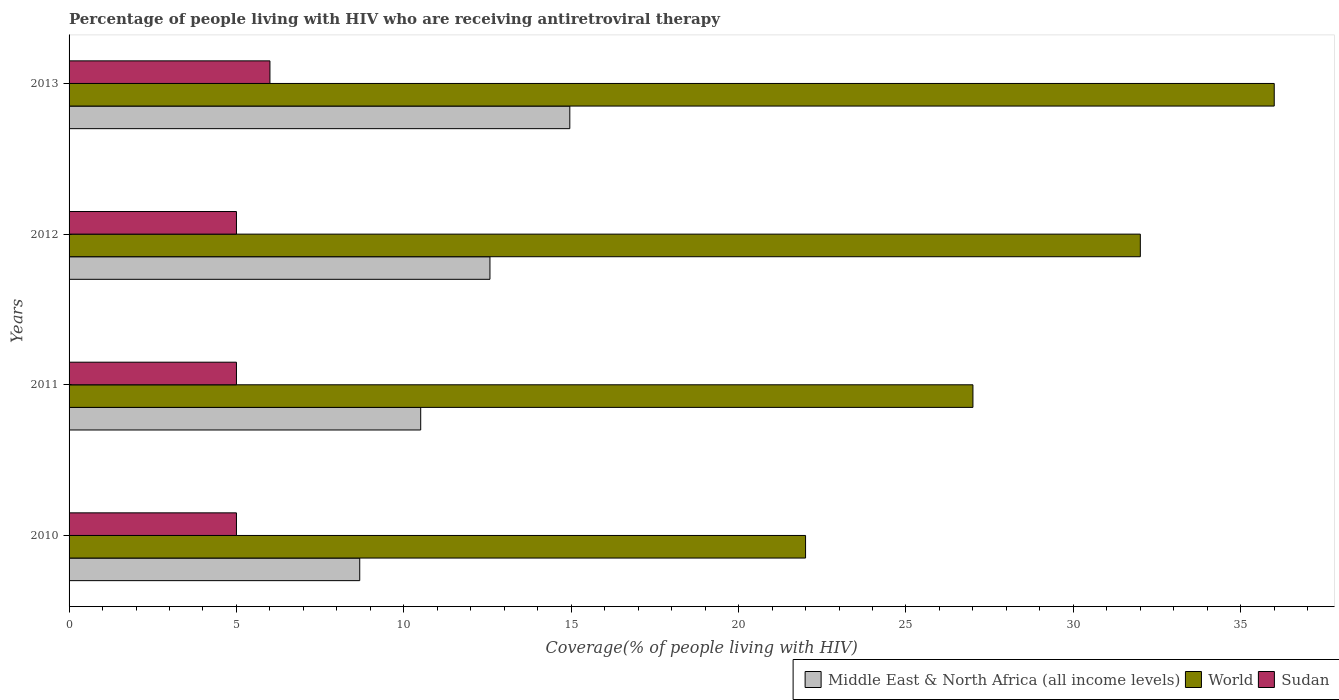How many different coloured bars are there?
Make the answer very short. 3. How many groups of bars are there?
Provide a short and direct response. 4. Are the number of bars per tick equal to the number of legend labels?
Keep it short and to the point. Yes. What is the percentage of the HIV infected people who are receiving antiretroviral therapy in Sudan in 2011?
Provide a succinct answer. 5. Across all years, what is the maximum percentage of the HIV infected people who are receiving antiretroviral therapy in World?
Your response must be concise. 36. Across all years, what is the minimum percentage of the HIV infected people who are receiving antiretroviral therapy in World?
Provide a short and direct response. 22. What is the total percentage of the HIV infected people who are receiving antiretroviral therapy in Middle East & North Africa (all income levels) in the graph?
Offer a terse response. 46.72. What is the difference between the percentage of the HIV infected people who are receiving antiretroviral therapy in Sudan in 2012 and that in 2013?
Give a very brief answer. -1. What is the difference between the percentage of the HIV infected people who are receiving antiretroviral therapy in Middle East & North Africa (all income levels) in 2011 and the percentage of the HIV infected people who are receiving antiretroviral therapy in Sudan in 2012?
Ensure brevity in your answer.  5.5. What is the average percentage of the HIV infected people who are receiving antiretroviral therapy in Middle East & North Africa (all income levels) per year?
Your answer should be very brief. 11.68. In the year 2010, what is the difference between the percentage of the HIV infected people who are receiving antiretroviral therapy in Middle East & North Africa (all income levels) and percentage of the HIV infected people who are receiving antiretroviral therapy in World?
Your answer should be very brief. -13.32. What is the ratio of the percentage of the HIV infected people who are receiving antiretroviral therapy in World in 2011 to that in 2013?
Your response must be concise. 0.75. Is the percentage of the HIV infected people who are receiving antiretroviral therapy in World in 2010 less than that in 2011?
Keep it short and to the point. Yes. What is the difference between the highest and the lowest percentage of the HIV infected people who are receiving antiretroviral therapy in World?
Make the answer very short. 14. In how many years, is the percentage of the HIV infected people who are receiving antiretroviral therapy in Sudan greater than the average percentage of the HIV infected people who are receiving antiretroviral therapy in Sudan taken over all years?
Make the answer very short. 1. Is it the case that in every year, the sum of the percentage of the HIV infected people who are receiving antiretroviral therapy in World and percentage of the HIV infected people who are receiving antiretroviral therapy in Middle East & North Africa (all income levels) is greater than the percentage of the HIV infected people who are receiving antiretroviral therapy in Sudan?
Provide a short and direct response. Yes. What is the difference between two consecutive major ticks on the X-axis?
Offer a terse response. 5. Are the values on the major ticks of X-axis written in scientific E-notation?
Keep it short and to the point. No. Does the graph contain any zero values?
Give a very brief answer. No. Where does the legend appear in the graph?
Keep it short and to the point. Bottom right. How many legend labels are there?
Offer a terse response. 3. How are the legend labels stacked?
Your response must be concise. Horizontal. What is the title of the graph?
Keep it short and to the point. Percentage of people living with HIV who are receiving antiretroviral therapy. What is the label or title of the X-axis?
Keep it short and to the point. Coverage(% of people living with HIV). What is the Coverage(% of people living with HIV) of Middle East & North Africa (all income levels) in 2010?
Make the answer very short. 8.68. What is the Coverage(% of people living with HIV) in Middle East & North Africa (all income levels) in 2011?
Your response must be concise. 10.5. What is the Coverage(% of people living with HIV) in Sudan in 2011?
Your response must be concise. 5. What is the Coverage(% of people living with HIV) in Middle East & North Africa (all income levels) in 2012?
Provide a succinct answer. 12.57. What is the Coverage(% of people living with HIV) of World in 2012?
Keep it short and to the point. 32. What is the Coverage(% of people living with HIV) of Sudan in 2012?
Keep it short and to the point. 5. What is the Coverage(% of people living with HIV) in Middle East & North Africa (all income levels) in 2013?
Your response must be concise. 14.96. Across all years, what is the maximum Coverage(% of people living with HIV) in Middle East & North Africa (all income levels)?
Provide a short and direct response. 14.96. Across all years, what is the minimum Coverage(% of people living with HIV) of Middle East & North Africa (all income levels)?
Your response must be concise. 8.68. Across all years, what is the minimum Coverage(% of people living with HIV) of Sudan?
Your answer should be compact. 5. What is the total Coverage(% of people living with HIV) of Middle East & North Africa (all income levels) in the graph?
Ensure brevity in your answer.  46.72. What is the total Coverage(% of people living with HIV) in World in the graph?
Offer a terse response. 117. What is the total Coverage(% of people living with HIV) of Sudan in the graph?
Your answer should be compact. 21. What is the difference between the Coverage(% of people living with HIV) in Middle East & North Africa (all income levels) in 2010 and that in 2011?
Keep it short and to the point. -1.82. What is the difference between the Coverage(% of people living with HIV) of World in 2010 and that in 2011?
Provide a short and direct response. -5. What is the difference between the Coverage(% of people living with HIV) of Sudan in 2010 and that in 2011?
Your answer should be very brief. 0. What is the difference between the Coverage(% of people living with HIV) of Middle East & North Africa (all income levels) in 2010 and that in 2012?
Ensure brevity in your answer.  -3.89. What is the difference between the Coverage(% of people living with HIV) in Middle East & North Africa (all income levels) in 2010 and that in 2013?
Offer a very short reply. -6.28. What is the difference between the Coverage(% of people living with HIV) in World in 2010 and that in 2013?
Provide a short and direct response. -14. What is the difference between the Coverage(% of people living with HIV) of Middle East & North Africa (all income levels) in 2011 and that in 2012?
Your response must be concise. -2.07. What is the difference between the Coverage(% of people living with HIV) of Middle East & North Africa (all income levels) in 2011 and that in 2013?
Ensure brevity in your answer.  -4.45. What is the difference between the Coverage(% of people living with HIV) of World in 2011 and that in 2013?
Your response must be concise. -9. What is the difference between the Coverage(% of people living with HIV) in Middle East & North Africa (all income levels) in 2012 and that in 2013?
Make the answer very short. -2.39. What is the difference between the Coverage(% of people living with HIV) of World in 2012 and that in 2013?
Provide a short and direct response. -4. What is the difference between the Coverage(% of people living with HIV) in Middle East & North Africa (all income levels) in 2010 and the Coverage(% of people living with HIV) in World in 2011?
Your answer should be very brief. -18.32. What is the difference between the Coverage(% of people living with HIV) of Middle East & North Africa (all income levels) in 2010 and the Coverage(% of people living with HIV) of Sudan in 2011?
Your response must be concise. 3.68. What is the difference between the Coverage(% of people living with HIV) in World in 2010 and the Coverage(% of people living with HIV) in Sudan in 2011?
Your response must be concise. 17. What is the difference between the Coverage(% of people living with HIV) of Middle East & North Africa (all income levels) in 2010 and the Coverage(% of people living with HIV) of World in 2012?
Give a very brief answer. -23.32. What is the difference between the Coverage(% of people living with HIV) of Middle East & North Africa (all income levels) in 2010 and the Coverage(% of people living with HIV) of Sudan in 2012?
Offer a terse response. 3.68. What is the difference between the Coverage(% of people living with HIV) in World in 2010 and the Coverage(% of people living with HIV) in Sudan in 2012?
Offer a terse response. 17. What is the difference between the Coverage(% of people living with HIV) in Middle East & North Africa (all income levels) in 2010 and the Coverage(% of people living with HIV) in World in 2013?
Keep it short and to the point. -27.32. What is the difference between the Coverage(% of people living with HIV) in Middle East & North Africa (all income levels) in 2010 and the Coverage(% of people living with HIV) in Sudan in 2013?
Ensure brevity in your answer.  2.68. What is the difference between the Coverage(% of people living with HIV) in World in 2010 and the Coverage(% of people living with HIV) in Sudan in 2013?
Keep it short and to the point. 16. What is the difference between the Coverage(% of people living with HIV) in Middle East & North Africa (all income levels) in 2011 and the Coverage(% of people living with HIV) in World in 2012?
Provide a succinct answer. -21.5. What is the difference between the Coverage(% of people living with HIV) of Middle East & North Africa (all income levels) in 2011 and the Coverage(% of people living with HIV) of Sudan in 2012?
Your answer should be very brief. 5.5. What is the difference between the Coverage(% of people living with HIV) in World in 2011 and the Coverage(% of people living with HIV) in Sudan in 2012?
Ensure brevity in your answer.  22. What is the difference between the Coverage(% of people living with HIV) of Middle East & North Africa (all income levels) in 2011 and the Coverage(% of people living with HIV) of World in 2013?
Keep it short and to the point. -25.5. What is the difference between the Coverage(% of people living with HIV) in Middle East & North Africa (all income levels) in 2011 and the Coverage(% of people living with HIV) in Sudan in 2013?
Offer a terse response. 4.5. What is the difference between the Coverage(% of people living with HIV) of Middle East & North Africa (all income levels) in 2012 and the Coverage(% of people living with HIV) of World in 2013?
Provide a short and direct response. -23.43. What is the difference between the Coverage(% of people living with HIV) in Middle East & North Africa (all income levels) in 2012 and the Coverage(% of people living with HIV) in Sudan in 2013?
Ensure brevity in your answer.  6.57. What is the difference between the Coverage(% of people living with HIV) of World in 2012 and the Coverage(% of people living with HIV) of Sudan in 2013?
Offer a terse response. 26. What is the average Coverage(% of people living with HIV) in Middle East & North Africa (all income levels) per year?
Give a very brief answer. 11.68. What is the average Coverage(% of people living with HIV) of World per year?
Give a very brief answer. 29.25. What is the average Coverage(% of people living with HIV) in Sudan per year?
Your answer should be compact. 5.25. In the year 2010, what is the difference between the Coverage(% of people living with HIV) of Middle East & North Africa (all income levels) and Coverage(% of people living with HIV) of World?
Give a very brief answer. -13.32. In the year 2010, what is the difference between the Coverage(% of people living with HIV) in Middle East & North Africa (all income levels) and Coverage(% of people living with HIV) in Sudan?
Give a very brief answer. 3.68. In the year 2011, what is the difference between the Coverage(% of people living with HIV) in Middle East & North Africa (all income levels) and Coverage(% of people living with HIV) in World?
Ensure brevity in your answer.  -16.5. In the year 2011, what is the difference between the Coverage(% of people living with HIV) in Middle East & North Africa (all income levels) and Coverage(% of people living with HIV) in Sudan?
Ensure brevity in your answer.  5.5. In the year 2011, what is the difference between the Coverage(% of people living with HIV) of World and Coverage(% of people living with HIV) of Sudan?
Your answer should be compact. 22. In the year 2012, what is the difference between the Coverage(% of people living with HIV) of Middle East & North Africa (all income levels) and Coverage(% of people living with HIV) of World?
Make the answer very short. -19.43. In the year 2012, what is the difference between the Coverage(% of people living with HIV) of Middle East & North Africa (all income levels) and Coverage(% of people living with HIV) of Sudan?
Provide a succinct answer. 7.57. In the year 2012, what is the difference between the Coverage(% of people living with HIV) in World and Coverage(% of people living with HIV) in Sudan?
Offer a terse response. 27. In the year 2013, what is the difference between the Coverage(% of people living with HIV) in Middle East & North Africa (all income levels) and Coverage(% of people living with HIV) in World?
Provide a short and direct response. -21.04. In the year 2013, what is the difference between the Coverage(% of people living with HIV) in Middle East & North Africa (all income levels) and Coverage(% of people living with HIV) in Sudan?
Your answer should be compact. 8.96. What is the ratio of the Coverage(% of people living with HIV) of Middle East & North Africa (all income levels) in 2010 to that in 2011?
Ensure brevity in your answer.  0.83. What is the ratio of the Coverage(% of people living with HIV) in World in 2010 to that in 2011?
Your answer should be compact. 0.81. What is the ratio of the Coverage(% of people living with HIV) in Sudan in 2010 to that in 2011?
Provide a succinct answer. 1. What is the ratio of the Coverage(% of people living with HIV) in Middle East & North Africa (all income levels) in 2010 to that in 2012?
Offer a very short reply. 0.69. What is the ratio of the Coverage(% of people living with HIV) in World in 2010 to that in 2012?
Your response must be concise. 0.69. What is the ratio of the Coverage(% of people living with HIV) in Sudan in 2010 to that in 2012?
Keep it short and to the point. 1. What is the ratio of the Coverage(% of people living with HIV) of Middle East & North Africa (all income levels) in 2010 to that in 2013?
Your answer should be very brief. 0.58. What is the ratio of the Coverage(% of people living with HIV) of World in 2010 to that in 2013?
Offer a terse response. 0.61. What is the ratio of the Coverage(% of people living with HIV) of Sudan in 2010 to that in 2013?
Provide a short and direct response. 0.83. What is the ratio of the Coverage(% of people living with HIV) in Middle East & North Africa (all income levels) in 2011 to that in 2012?
Your answer should be very brief. 0.84. What is the ratio of the Coverage(% of people living with HIV) of World in 2011 to that in 2012?
Your answer should be very brief. 0.84. What is the ratio of the Coverage(% of people living with HIV) in Sudan in 2011 to that in 2012?
Your answer should be compact. 1. What is the ratio of the Coverage(% of people living with HIV) in Middle East & North Africa (all income levels) in 2011 to that in 2013?
Ensure brevity in your answer.  0.7. What is the ratio of the Coverage(% of people living with HIV) of Sudan in 2011 to that in 2013?
Offer a very short reply. 0.83. What is the ratio of the Coverage(% of people living with HIV) of Middle East & North Africa (all income levels) in 2012 to that in 2013?
Keep it short and to the point. 0.84. What is the ratio of the Coverage(% of people living with HIV) of World in 2012 to that in 2013?
Your answer should be compact. 0.89. What is the difference between the highest and the second highest Coverage(% of people living with HIV) in Middle East & North Africa (all income levels)?
Keep it short and to the point. 2.39. What is the difference between the highest and the second highest Coverage(% of people living with HIV) of Sudan?
Your answer should be compact. 1. What is the difference between the highest and the lowest Coverage(% of people living with HIV) of Middle East & North Africa (all income levels)?
Offer a terse response. 6.28. What is the difference between the highest and the lowest Coverage(% of people living with HIV) in World?
Make the answer very short. 14. What is the difference between the highest and the lowest Coverage(% of people living with HIV) in Sudan?
Offer a very short reply. 1. 